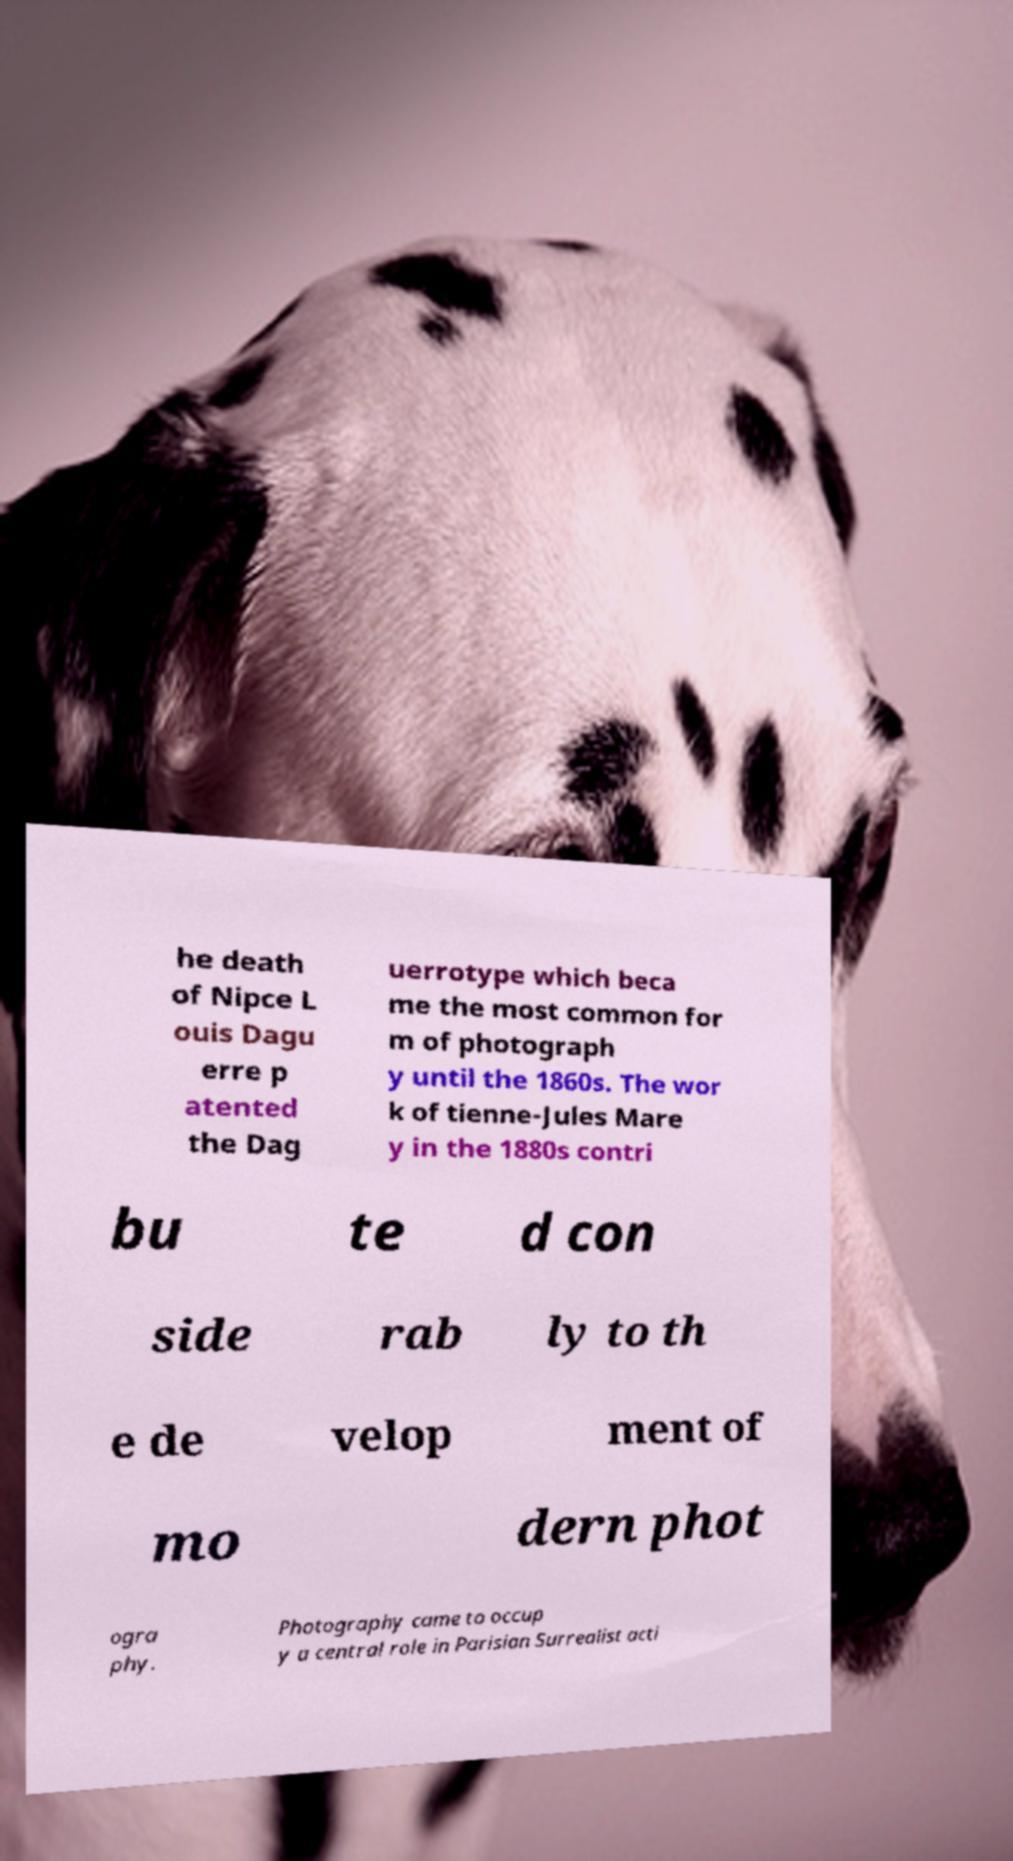There's text embedded in this image that I need extracted. Can you transcribe it verbatim? he death of Nipce L ouis Dagu erre p atented the Dag uerrotype which beca me the most common for m of photograph y until the 1860s. The wor k of tienne-Jules Mare y in the 1880s contri bu te d con side rab ly to th e de velop ment of mo dern phot ogra phy. Photography came to occup y a central role in Parisian Surrealist acti 